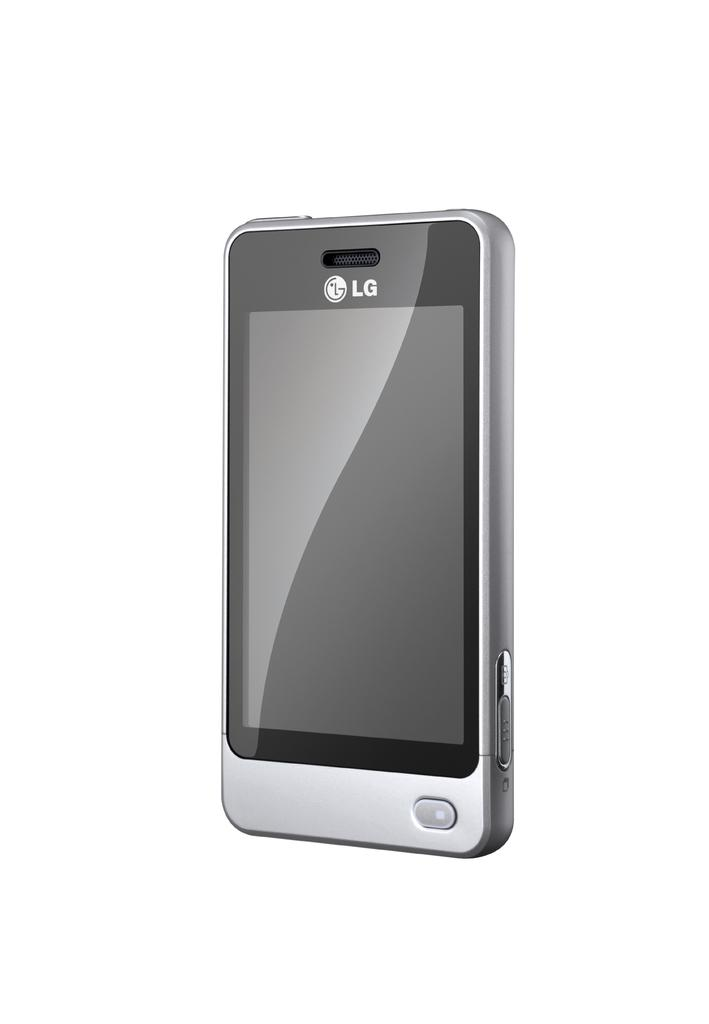<image>
Offer a succinct explanation of the picture presented. A silver LG brand smartphone with a single button on the lower edge 